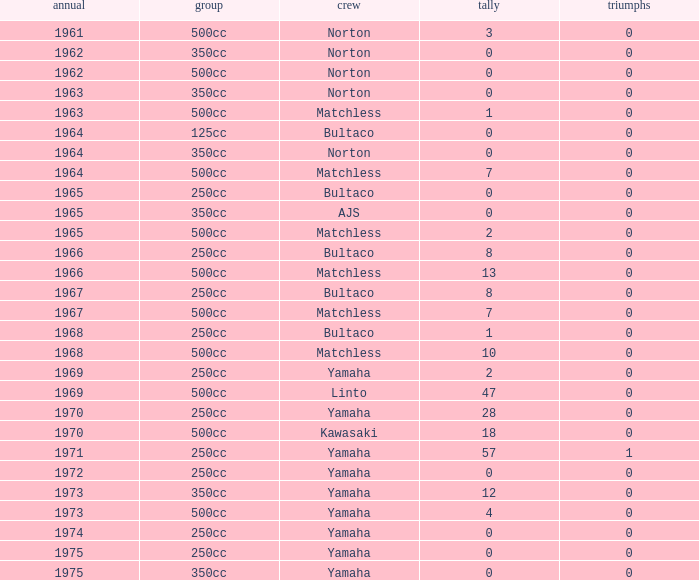Would you be able to parse every entry in this table? {'header': ['annual', 'group', 'crew', 'tally', 'triumphs'], 'rows': [['1961', '500cc', 'Norton', '3', '0'], ['1962', '350cc', 'Norton', '0', '0'], ['1962', '500cc', 'Norton', '0', '0'], ['1963', '350cc', 'Norton', '0', '0'], ['1963', '500cc', 'Matchless', '1', '0'], ['1964', '125cc', 'Bultaco', '0', '0'], ['1964', '350cc', 'Norton', '0', '0'], ['1964', '500cc', 'Matchless', '7', '0'], ['1965', '250cc', 'Bultaco', '0', '0'], ['1965', '350cc', 'AJS', '0', '0'], ['1965', '500cc', 'Matchless', '2', '0'], ['1966', '250cc', 'Bultaco', '8', '0'], ['1966', '500cc', 'Matchless', '13', '0'], ['1967', '250cc', 'Bultaco', '8', '0'], ['1967', '500cc', 'Matchless', '7', '0'], ['1968', '250cc', 'Bultaco', '1', '0'], ['1968', '500cc', 'Matchless', '10', '0'], ['1969', '250cc', 'Yamaha', '2', '0'], ['1969', '500cc', 'Linto', '47', '0'], ['1970', '250cc', 'Yamaha', '28', '0'], ['1970', '500cc', 'Kawasaki', '18', '0'], ['1971', '250cc', 'Yamaha', '57', '1'], ['1972', '250cc', 'Yamaha', '0', '0'], ['1973', '350cc', 'Yamaha', '12', '0'], ['1973', '500cc', 'Yamaha', '4', '0'], ['1974', '250cc', 'Yamaha', '0', '0'], ['1975', '250cc', 'Yamaha', '0', '0'], ['1975', '350cc', 'Yamaha', '0', '0']]} What is the sum of all points in 1975 with 0 wins? None. 